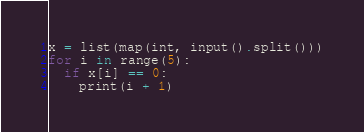<code> <loc_0><loc_0><loc_500><loc_500><_Python_>x = list(map(int, input().split()))
for i in range(5):
  if x[i] == 0:
    print(i + 1)
</code> 